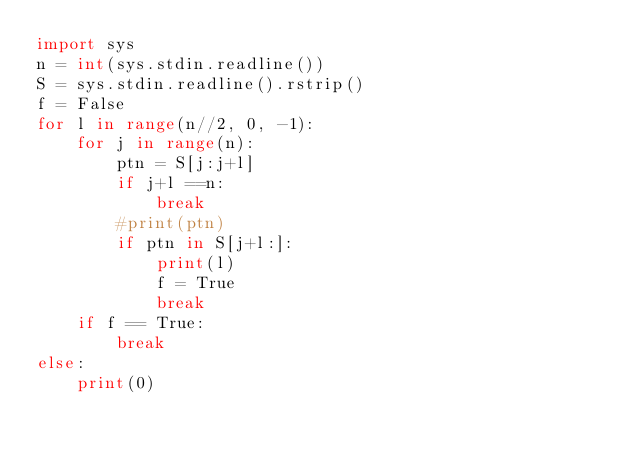Convert code to text. <code><loc_0><loc_0><loc_500><loc_500><_Python_>import sys
n = int(sys.stdin.readline())
S = sys.stdin.readline().rstrip()
f = False
for l in range(n//2, 0, -1):
    for j in range(n):
        ptn = S[j:j+l]
        if j+l ==n:
            break
        #print(ptn)
        if ptn in S[j+l:]:
            print(l)
            f = True
            break
    if f == True:
        break
else:
    print(0)</code> 